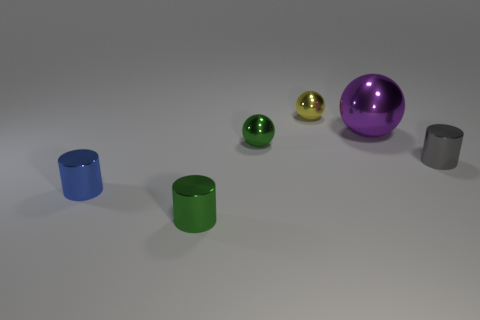There is a tiny object behind the small green shiny object that is on the right side of the tiny green metallic object that is in front of the gray metal cylinder; what shape is it?
Provide a succinct answer. Sphere. Is the size of the green metallic cylinder the same as the ball in front of the large purple metallic sphere?
Your response must be concise. Yes. What is the color of the metallic cylinder that is in front of the tiny gray metallic thing and right of the small blue cylinder?
Provide a short and direct response. Green. Do the tiny metal sphere that is in front of the large purple thing and the object that is in front of the small blue shiny thing have the same color?
Provide a short and direct response. Yes. Does the ball in front of the purple thing have the same size as the ball right of the yellow metallic object?
Make the answer very short. No. Is there any other thing that is the same material as the gray cylinder?
Offer a very short reply. Yes. Do the small yellow thing and the small blue object have the same shape?
Ensure brevity in your answer.  No. What number of other large shiny things have the same color as the big metal thing?
Your response must be concise. 0. What is the size of the purple object that is made of the same material as the gray cylinder?
Your answer should be very brief. Large. How many blue objects are either tiny metal objects or large objects?
Your response must be concise. 1. 